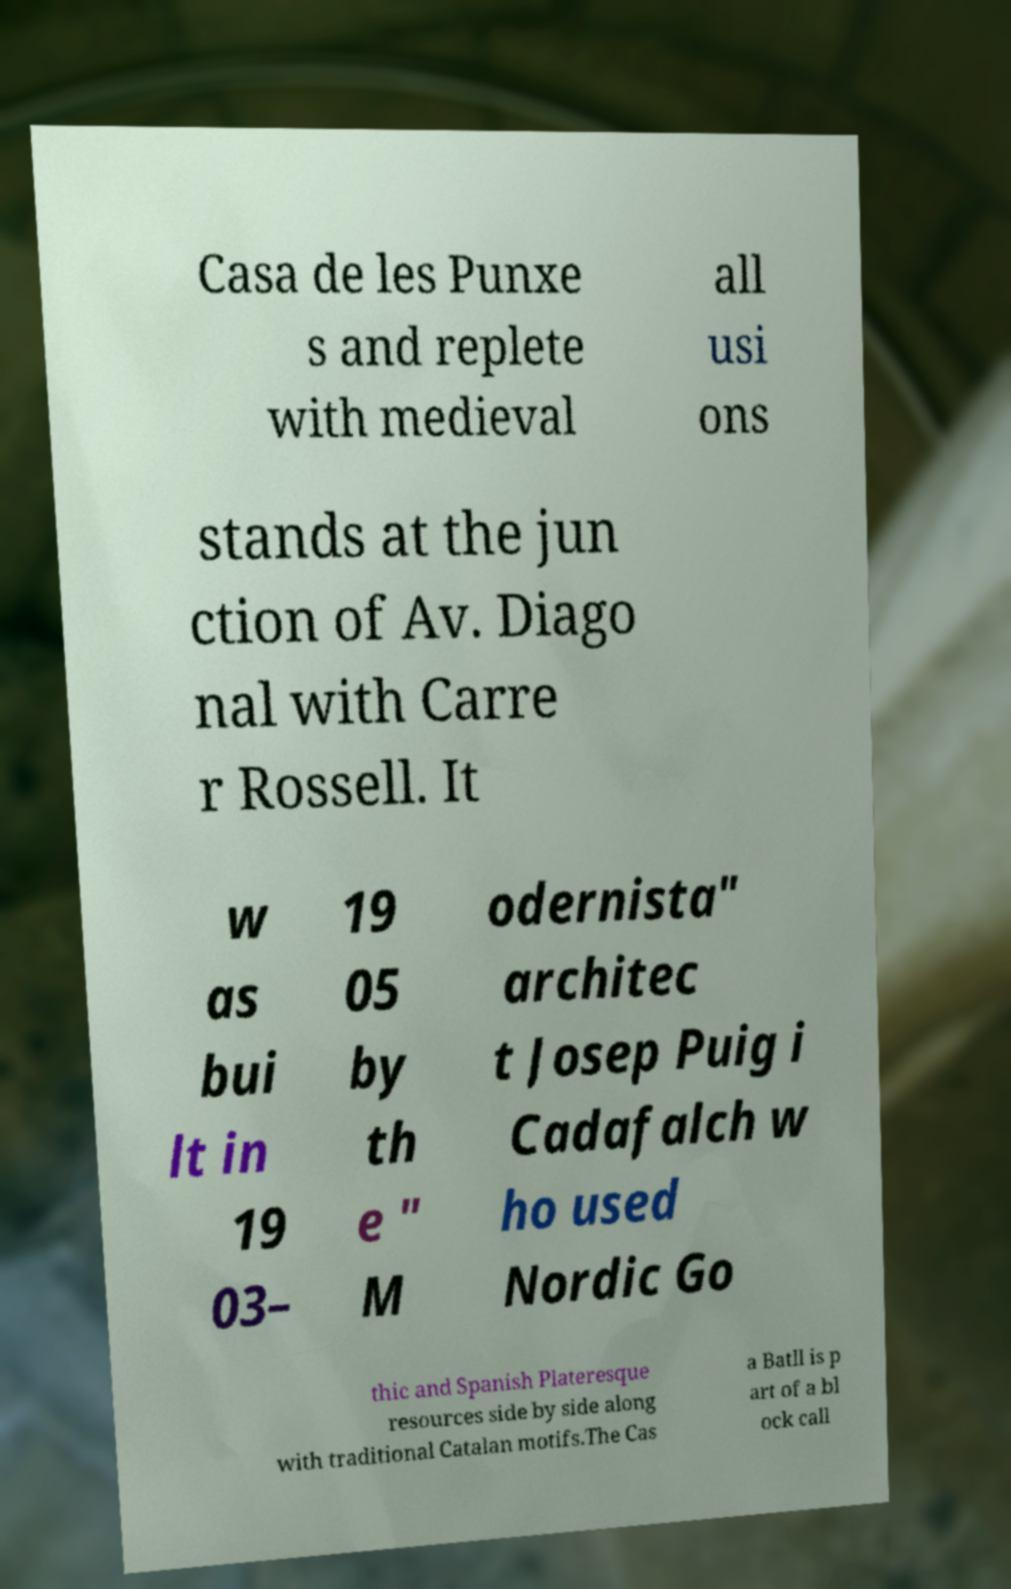Can you accurately transcribe the text from the provided image for me? Casa de les Punxe s and replete with medieval all usi ons stands at the jun ction of Av. Diago nal with Carre r Rossell. It w as bui lt in 19 03– 19 05 by th e " M odernista" architec t Josep Puig i Cadafalch w ho used Nordic Go thic and Spanish Plateresque resources side by side along with traditional Catalan motifs.The Cas a Batll is p art of a bl ock call 